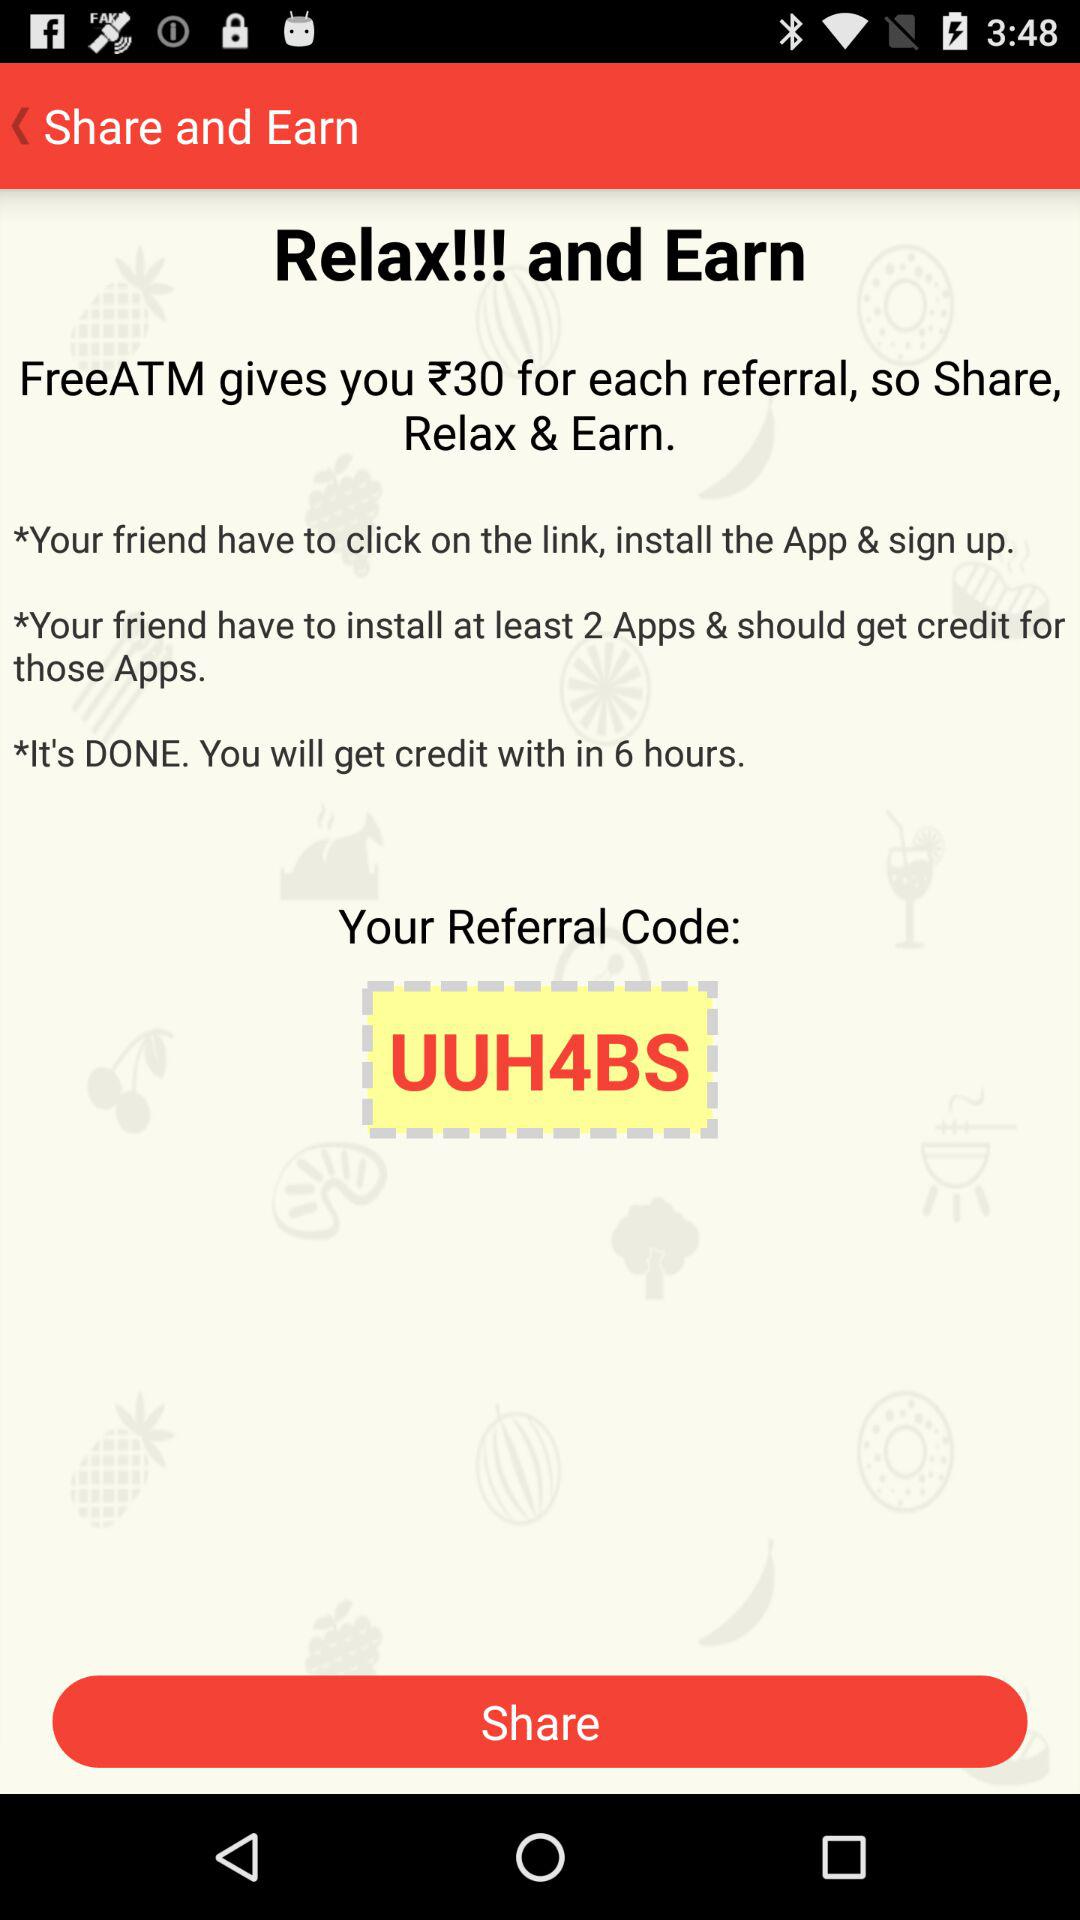How much will FreeATM give you for each referral? FreeATM will give ₹30 for each referral. 